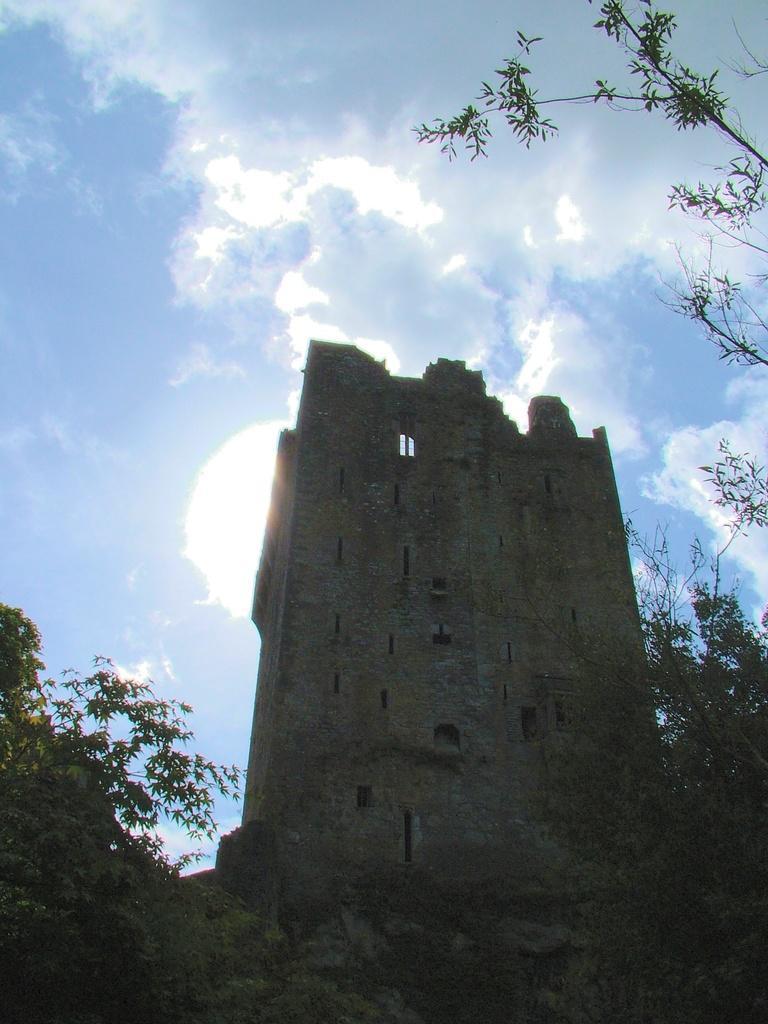What is the main structure in the image? There is a monument in the image. What type of vegetation can be seen in the image? There are trees, plants, and grass in the image. What is visible in the background of the image? The sky is visible in the background of the image, and there are clouds present. Reasoning: Let' Let's think step by step in order to produce the conversation. We start by identifying the main subject in the image, which is the monument. Then, we expand the conversation to include other elements in the image, such as the different types of vegetation and the sky in the background. Each question is designed to elicit a specific detail about the image that is known from the provided facts. Absurd Question/Answer: How many spiders are crawling on the monument in the image? There are no spiders present in the image; it only features a monument, trees, plants, grass, and a sky with clouds. How many spiders are crawling on the monument in the image? There are no spiders present in the image; it only features a monument, trees, plants, grass, and a sky with clouds. 